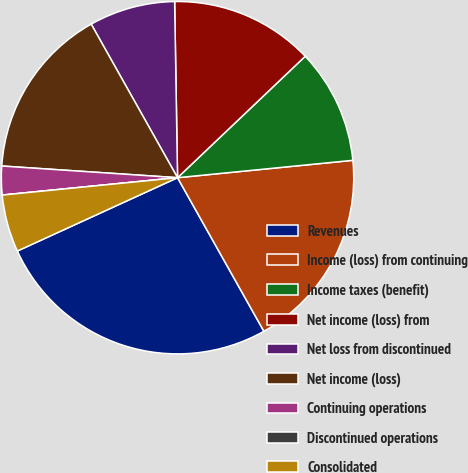Convert chart. <chart><loc_0><loc_0><loc_500><loc_500><pie_chart><fcel>Revenues<fcel>Income (loss) from continuing<fcel>Income taxes (benefit)<fcel>Net income (loss) from<fcel>Net loss from discontinued<fcel>Net income (loss)<fcel>Continuing operations<fcel>Discontinued operations<fcel>Consolidated<nl><fcel>26.32%<fcel>18.42%<fcel>10.53%<fcel>13.16%<fcel>7.89%<fcel>15.79%<fcel>2.63%<fcel>0.0%<fcel>5.26%<nl></chart> 